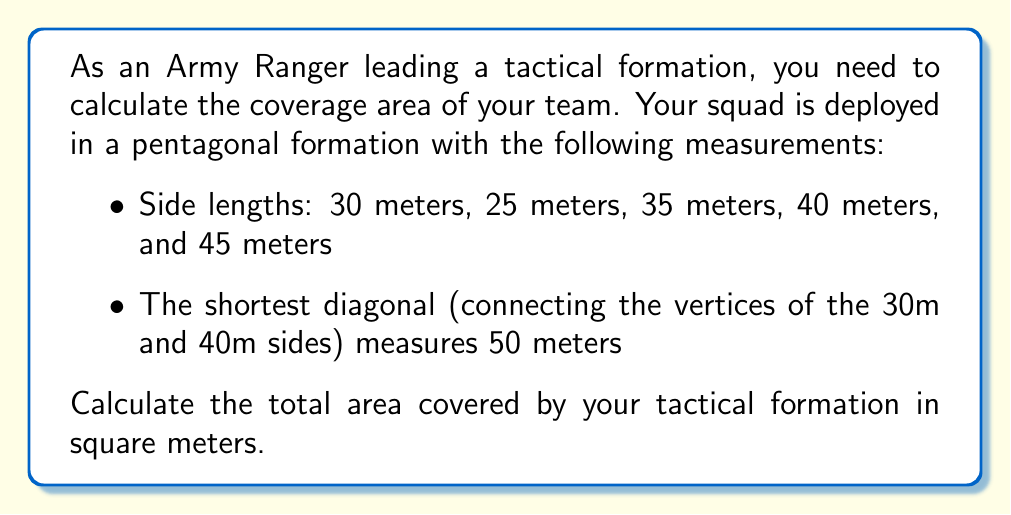Give your solution to this math problem. To solve this problem, we'll use the following approach:

1. Divide the pentagon into three triangles using the given diagonal.
2. Calculate the areas of these triangles using Heron's formula.
3. Sum the areas of the triangles to get the total area of the pentagon.

Step 1: Divide the pentagon into three triangles
Let's label the vertices A, B, C, D, and E, with the diagonal connecting A and D.

[asy]
unitsize(2mm);
pair A=(0,0), B=(30,0), C=(50,20), D=(30,40), E=(0,30);
draw(A--B--C--D--E--A);
draw(A--D);
label("A", A, SW);
label("B", B, SE);
label("C", C, E);
label("D", D, N);
label("E", E, W);
label("30m", (A+B)/2, S);
label("25m", (B+C)/2, SE);
label("35m", (C+D)/2, NE);
label("40m", (D+E)/2, NW);
label("45m", (E+A)/2, SW);
label("50m", (A+D)/2, NE);
[/asy]

Step 2: Calculate the areas of the triangles using Heron's formula

Heron's formula: $A = \sqrt{s(s-a)(s-b)(s-c)}$
where $s = \frac{a+b+c}{2}$ (semi-perimeter) and $a$, $b$, $c$ are the side lengths.

Triangle ABD:
$a = 30$, $b = 40$, $c = 50$
$s = \frac{30+40+50}{2} = 60$
$A_{ABD} = \sqrt{60(60-30)(60-40)(60-50)} = \sqrt{60 \cdot 30 \cdot 20 \cdot 10} = 600$ sq meters

Triangle BCD:
$a = 25$, $b = 35$, $c = 50$
$s = \frac{25+35+50}{2} = 55$
$A_{BCD} = \sqrt{55(55-25)(55-35)(55-50)} = \sqrt{55 \cdot 30 \cdot 20 \cdot 5} \approx 456.76$ sq meters

Triangle ADE:
$a = 45$, $b = 40$, $c = 50$
$s = \frac{45+40+50}{2} = 67.5$
$A_{ADE} = \sqrt{67.5(67.5-45)(67.5-40)(67.5-50)} = \sqrt{67.5 \cdot 22.5 \cdot 27.5 \cdot 17.5} \approx 771.39$ sq meters

Step 3: Sum the areas of the triangles
Total Area = $A_{ABD} + A_{BCD} + A_{ADE}$
Total Area $= 600 + 456.76 + 771.39 = 1828.15$ sq meters
Answer: The total area covered by the tactical formation is approximately 1828.15 square meters. 